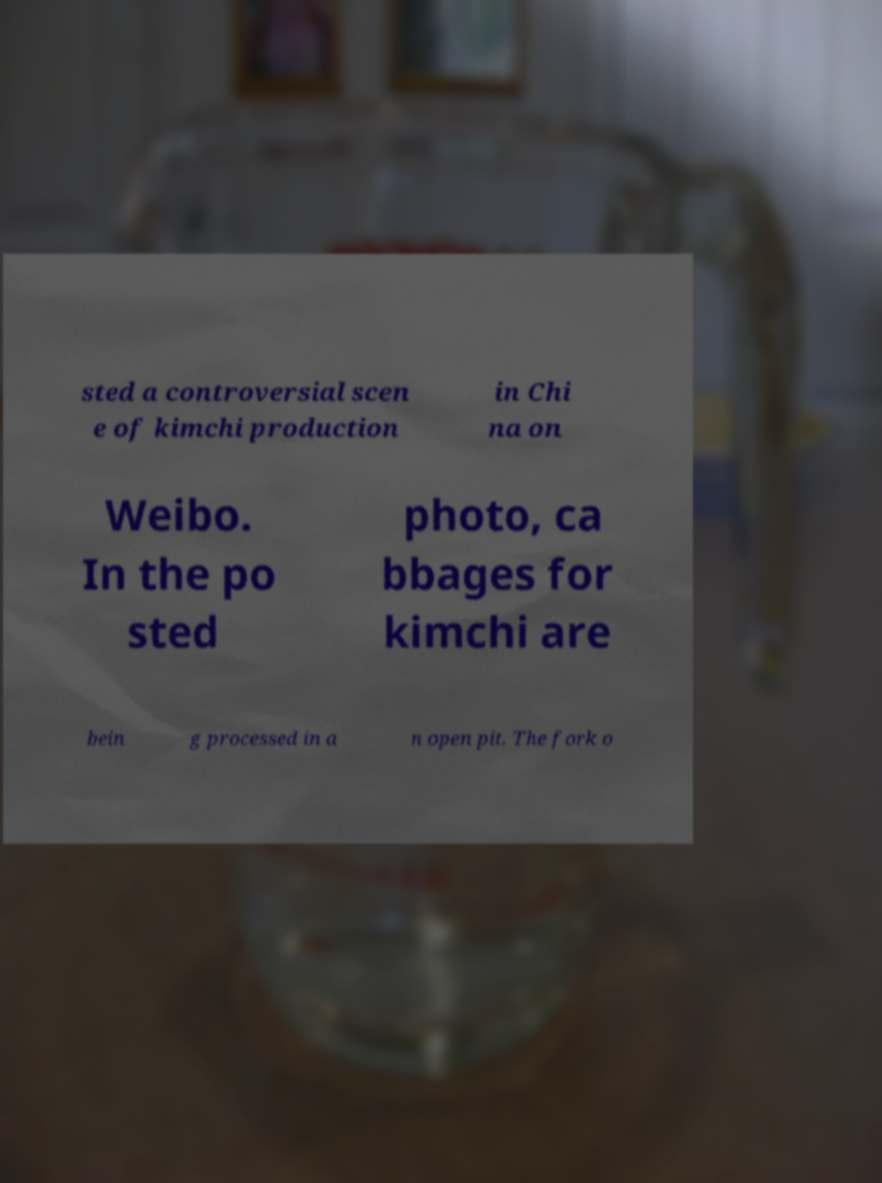What messages or text are displayed in this image? I need them in a readable, typed format. sted a controversial scen e of kimchi production in Chi na on Weibo. In the po sted photo, ca bbages for kimchi are bein g processed in a n open pit. The fork o 